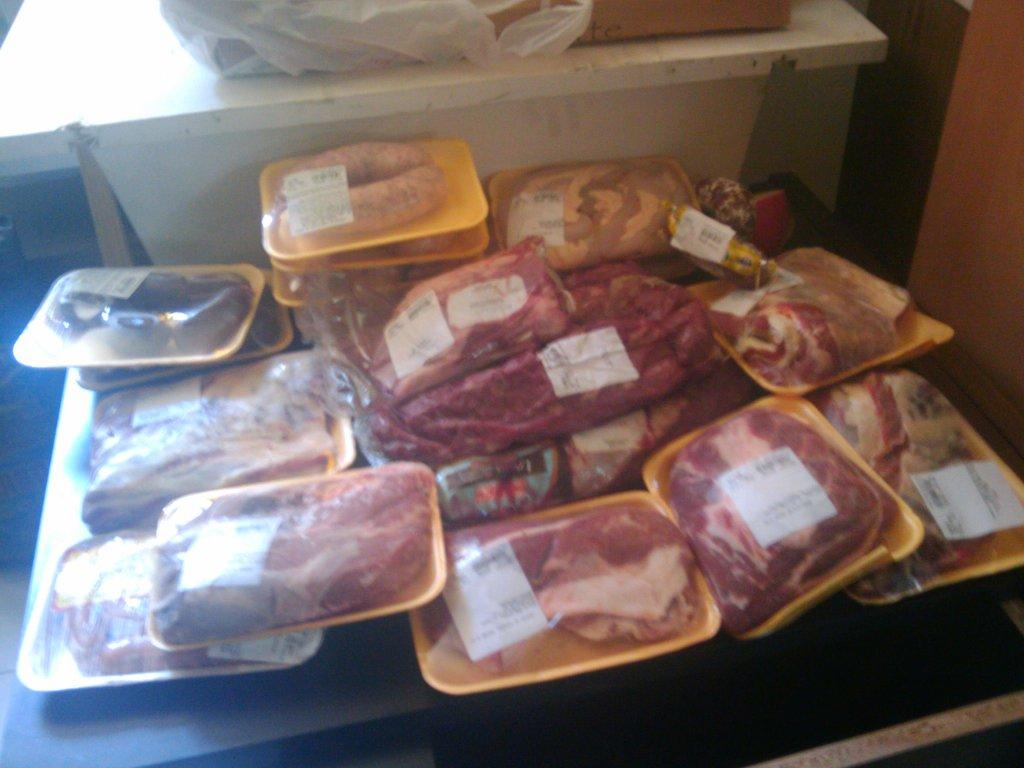What type of objects can be seen in the image? There are food items in the image. How are the food items arranged or contained? The food items are kept in a tray. Is there any protection or covering for the tray? Yes, the tray is wrapped in a cover. Can you identify any additional information about the food items? There is a label visible in the image. What is the color of the table in the image? The table is white in color. What type of engine can be seen powering the food items in the image? There is no engine present in the image, and the food items are not powered. 